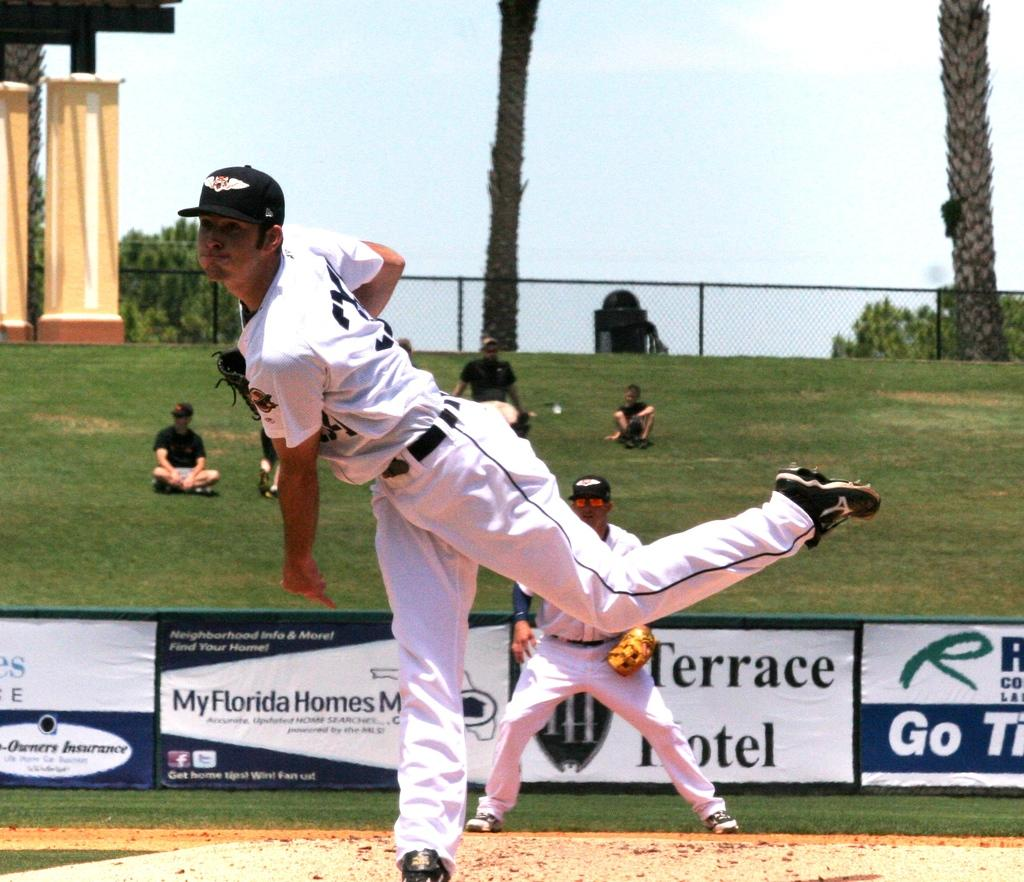<image>
Give a short and clear explanation of the subsequent image. A man pitches a ball with an ad for Terrace Hotel behind him. 